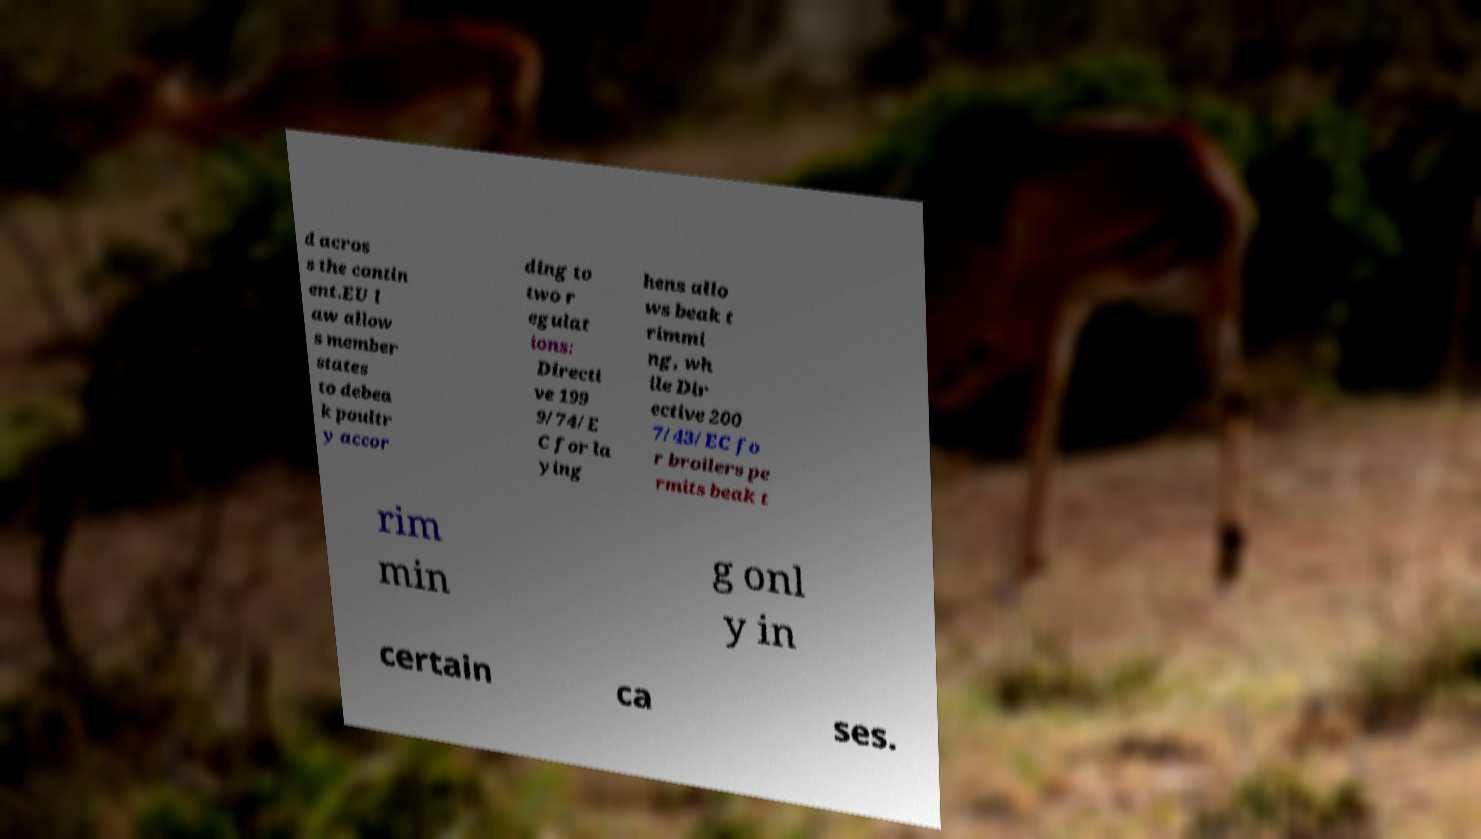Can you accurately transcribe the text from the provided image for me? d acros s the contin ent.EU l aw allow s member states to debea k poultr y accor ding to two r egulat ions: Directi ve 199 9/74/E C for la ying hens allo ws beak t rimmi ng, wh ile Dir ective 200 7/43/EC fo r broilers pe rmits beak t rim min g onl y in certain ca ses. 